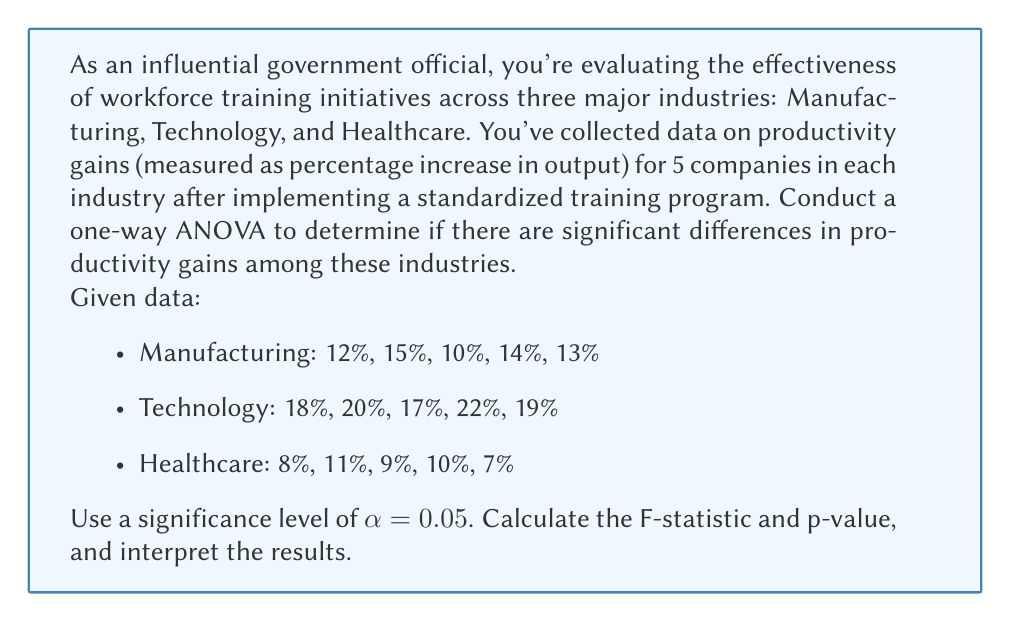Can you solve this math problem? To conduct a one-way ANOVA, we'll follow these steps:

1. Calculate the sum of squares between groups (SSB) and within groups (SSW).
2. Calculate the degrees of freedom for between groups (dfB) and within groups (dfW).
3. Calculate the mean squares for between groups (MSB) and within groups (MSW).
4. Calculate the F-statistic.
5. Determine the critical F-value and p-value.
6. Interpret the results.

Step 1: Calculate SSB and SSW

First, we need to calculate the grand mean and group means:

Grand mean: $\bar{X} = \frac{(12+15+10+14+13+18+20+17+22+19+8+11+9+10+7)}{15} = 13.67\%$

Group means:
Manufacturing: $\bar{X}_M = 12.8\%$
Technology: $\bar{X}_T = 19.2\%$
Healthcare: $\bar{X}_H = 9\%$

Now, we can calculate SSB:
$$SSB = 5[(12.8 - 13.67)^2 + (19.2 - 13.67)^2 + (9 - 13.67)^2] = 270.13$$

To calculate SSW, we sum the squared deviations within each group:

Manufacturing: $(12-12.8)^2 + (15-12.8)^2 + (10-12.8)^2 + (14-12.8)^2 + (13-12.8)^2 = 14.8$
Technology: $(18-19.2)^2 + (20-19.2)^2 + (17-19.2)^2 + (22-19.2)^2 + (19-19.2)^2 = 14.8$
Healthcare: $(8-9)^2 + (11-9)^2 + (9-9)^2 + (10-9)^2 + (7-9)^2 = 10$

$$SSW = 14.8 + 14.8 + 10 = 39.6$$

Step 2: Calculate degrees of freedom

$$dfB = k - 1 = 3 - 1 = 2$$
$$dfW = N - k = 15 - 3 = 12$$

where k is the number of groups and N is the total number of observations.

Step 3: Calculate mean squares

$$MSB = \frac{SSB}{dfB} = \frac{270.13}{2} = 135.065$$
$$MSW = \frac{SSW}{dfW} = \frac{39.6}{12} = 3.3$$

Step 4: Calculate F-statistic

$$F = \frac{MSB}{MSW} = \frac{135.065}{3.3} = 40.93$$

Step 5: Determine critical F-value and p-value

For $\alpha = 0.05$, $dfB = 2$, and $dfW = 12$, the critical F-value is approximately 3.89.

The p-value for F = 40.93 with dfB = 2 and dfW = 12 is less than 0.0001.

Step 6: Interpret the results

Since the calculated F-statistic (40.93) is greater than the critical F-value (3.89), and the p-value (< 0.0001) is less than the significance level (0.05), we reject the null hypothesis. This means there are significant differences in productivity gains among the three industries.
Answer: F-statistic: 40.93
p-value: < 0.0001

Interpretation: There are statistically significant differences in productivity gains among the Manufacturing, Technology, and Healthcare industries after implementing the standardized training program (F(2,12) = 40.93, p < 0.0001). This suggests that the effectiveness of the workforce training initiative varies across these industries, with Technology showing the highest average productivity gain (19.2%), followed by Manufacturing (12.8%), and Healthcare (9%). 